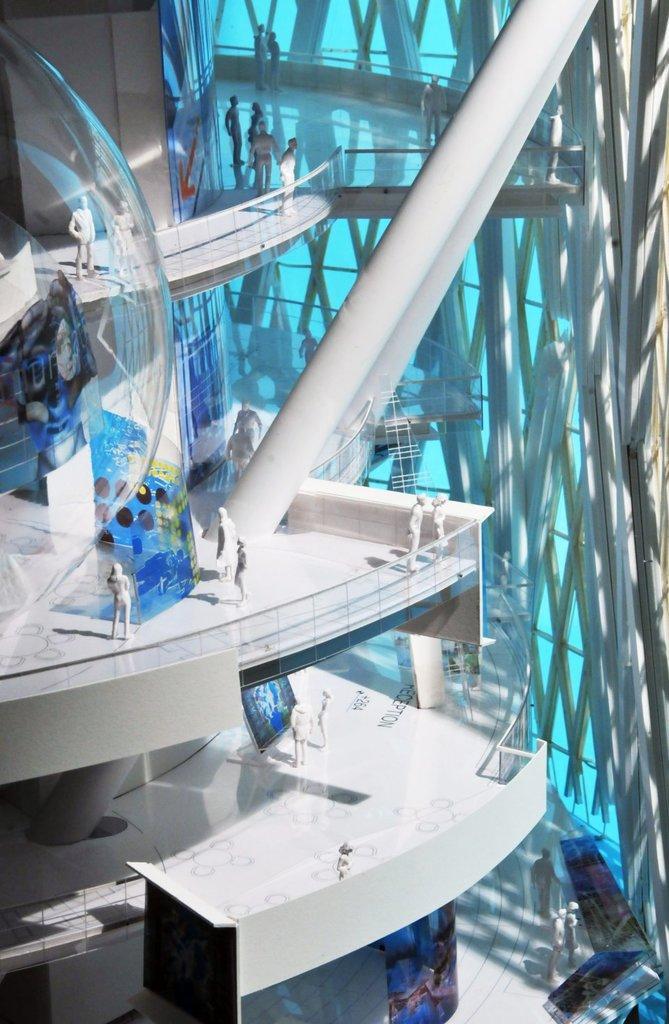Can you describe this image briefly? In the picture we can see a construction model of three floor with some people sculptures standing on the floors and beside it we can see a poles. 